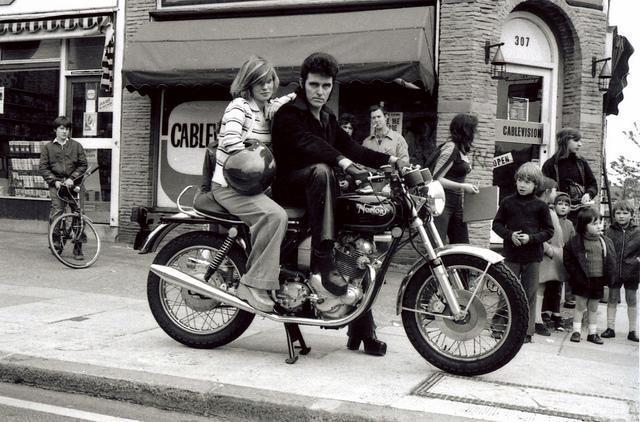How many people are on the motorcycle?
Give a very brief answer. 2. How many girls are on bikes?
Give a very brief answer. 1. How many people are there?
Give a very brief answer. 9. 